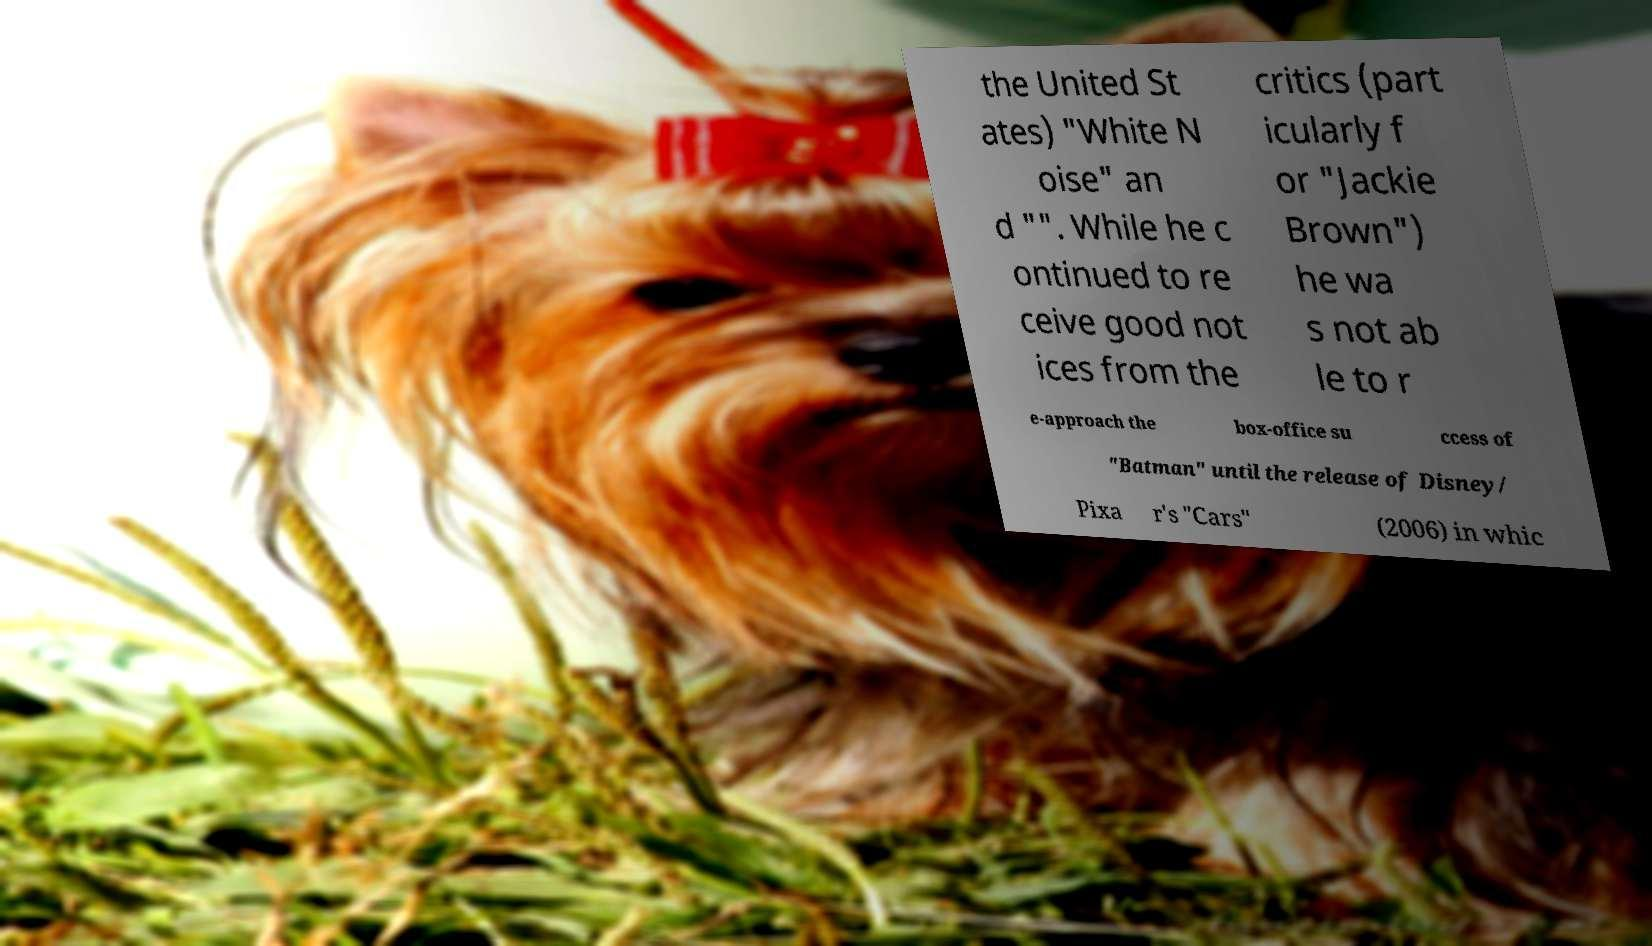Could you assist in decoding the text presented in this image and type it out clearly? the United St ates) "White N oise" an d "". While he c ontinued to re ceive good not ices from the critics (part icularly f or "Jackie Brown") he wa s not ab le to r e-approach the box-office su ccess of "Batman" until the release of Disney/ Pixa r's "Cars" (2006) in whic 